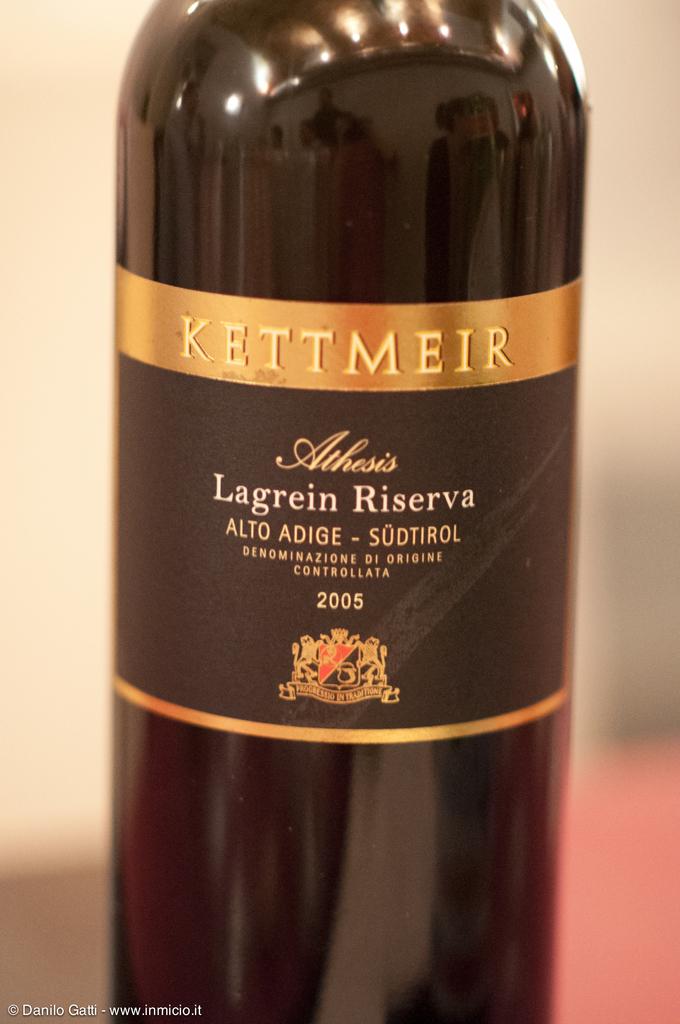What is the brand of wine?
Make the answer very short. Kettmeir. What year is the wine?
Give a very brief answer. 2005. 